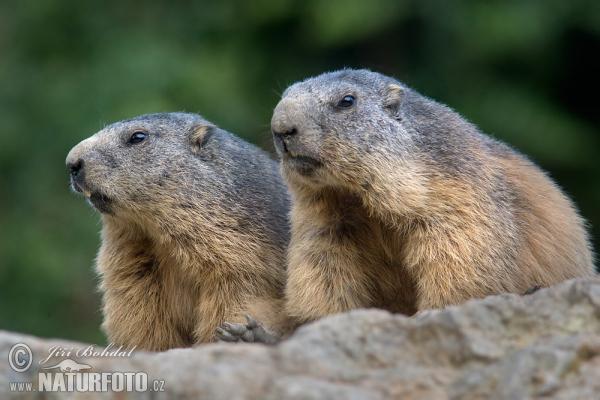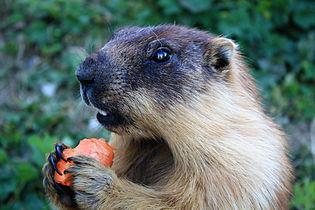The first image is the image on the left, the second image is the image on the right. Given the left and right images, does the statement "The animal in the image on the right is holding orange food." hold true? Answer yes or no. Yes. The first image is the image on the left, the second image is the image on the right. For the images shown, is this caption "Two animals are eating in the image on the right." true? Answer yes or no. No. The first image is the image on the left, the second image is the image on the right. Evaluate the accuracy of this statement regarding the images: "Right image shows two upright marmots with hands clasping something.". Is it true? Answer yes or no. No. 